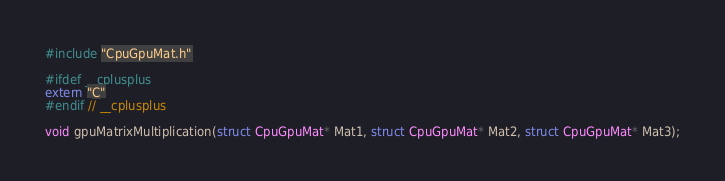<code> <loc_0><loc_0><loc_500><loc_500><_Cuda_>#include "CpuGpuMat.h"

#ifdef __cplusplus									
extern "C"
#endif // __cplusplus

void gpuMatrixMultiplication(struct CpuGpuMat* Mat1, struct CpuGpuMat* Mat2, struct CpuGpuMat* Mat3);
</code> 